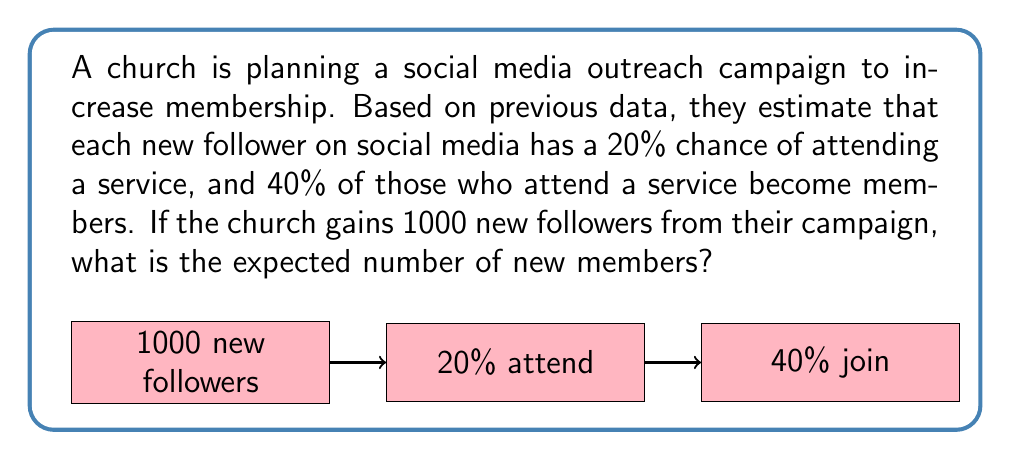Can you solve this math problem? Let's approach this step-by-step:

1) First, we need to calculate the probability of a new follower becoming a member. This is a two-step process:
   - 20% chance of attending a service
   - 40% chance of becoming a member if they attend

   We can calculate this as: $0.20 \times 0.40 = 0.08$ or 8%

2) Now, we can use the formula for expected value:
   $E(X) = n \times p$
   Where:
   $E(X)$ is the expected value
   $n$ is the number of trials (new followers)
   $p$ is the probability of success (becoming a member)

3) Plugging in our values:
   $E(X) = 1000 \times 0.08 = 80$

Therefore, the expected number of new members is 80.

This can also be thought of as:
$$ 1000 \text{ followers} \times 0.20 \text{ attend} \times 0.40 \text{ join} = 80 \text{ new members} $$
Answer: 80 new members 